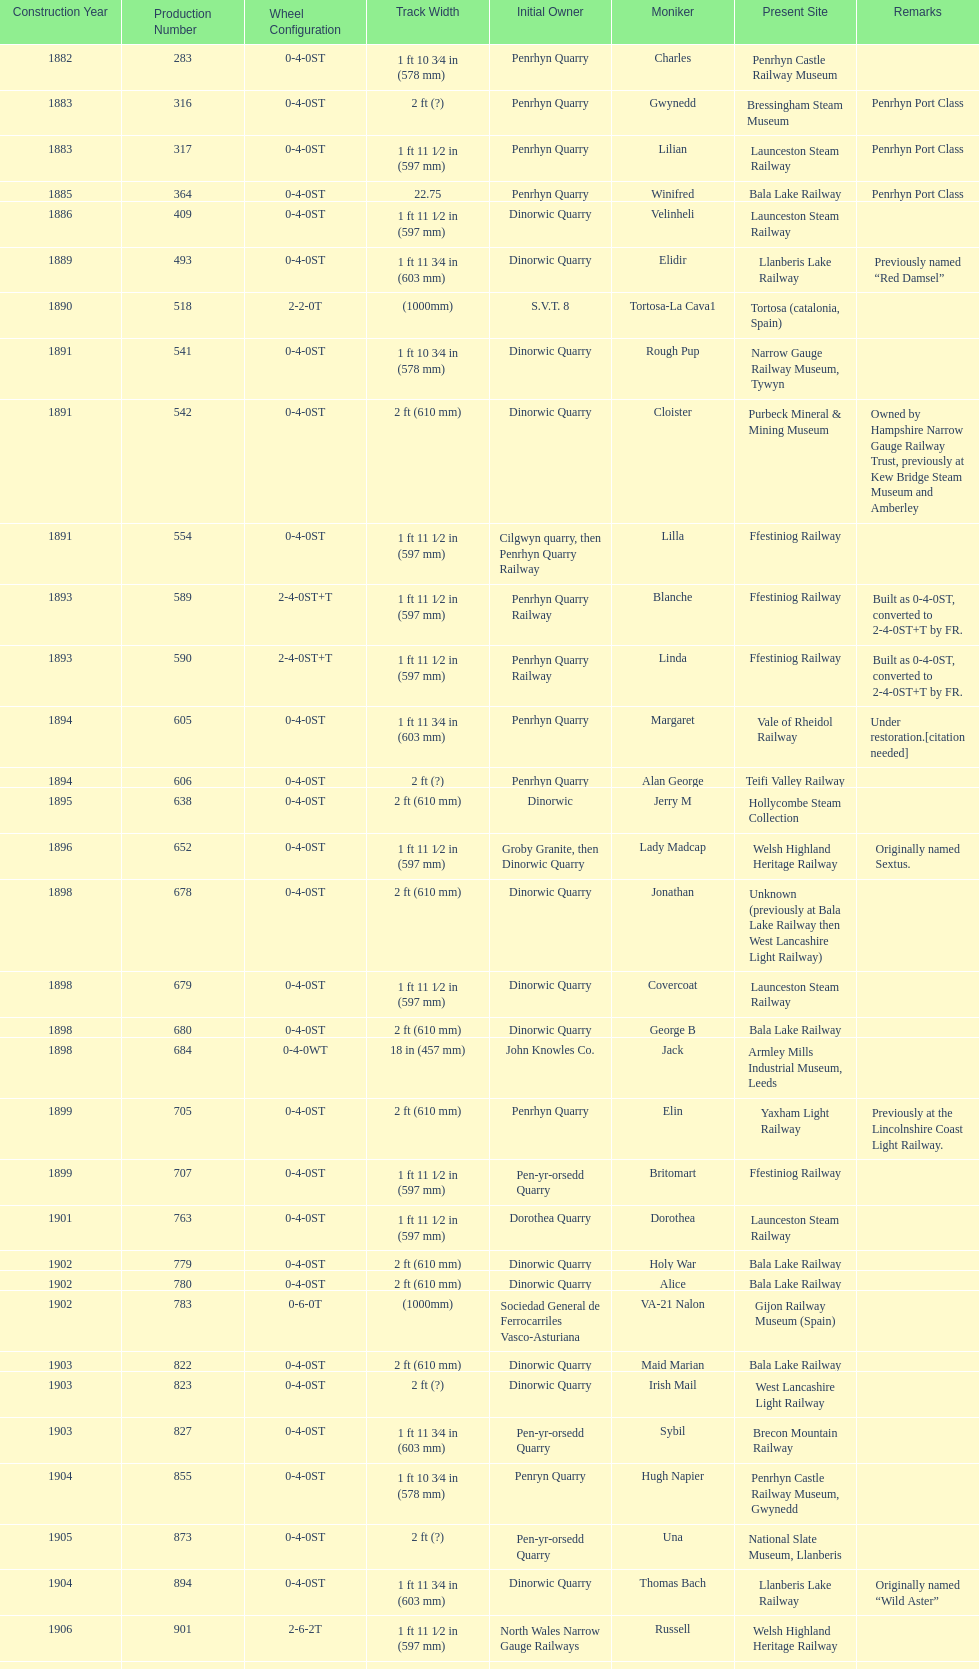How many steam locomotives are currently located at the bala lake railway? 364. 